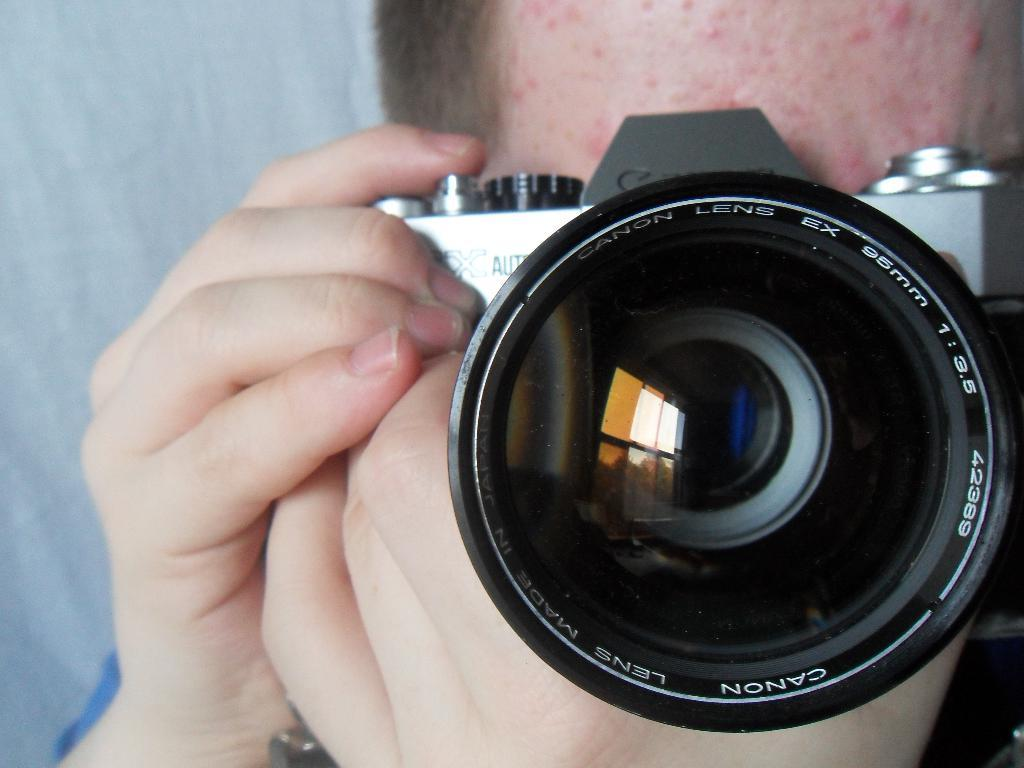Who or what is present in the image? There is a person in the image. What is the person holding? The person is holding a camera. Can you describe the object on the left side of the image? There is a white color object on the left side of the image. What type of iron can be seen in the image? There is no iron present in the image. Is there a badge visible on the person in the image? The facts provided do not mention a badge, so we cannot determine if one is visible in the image. 